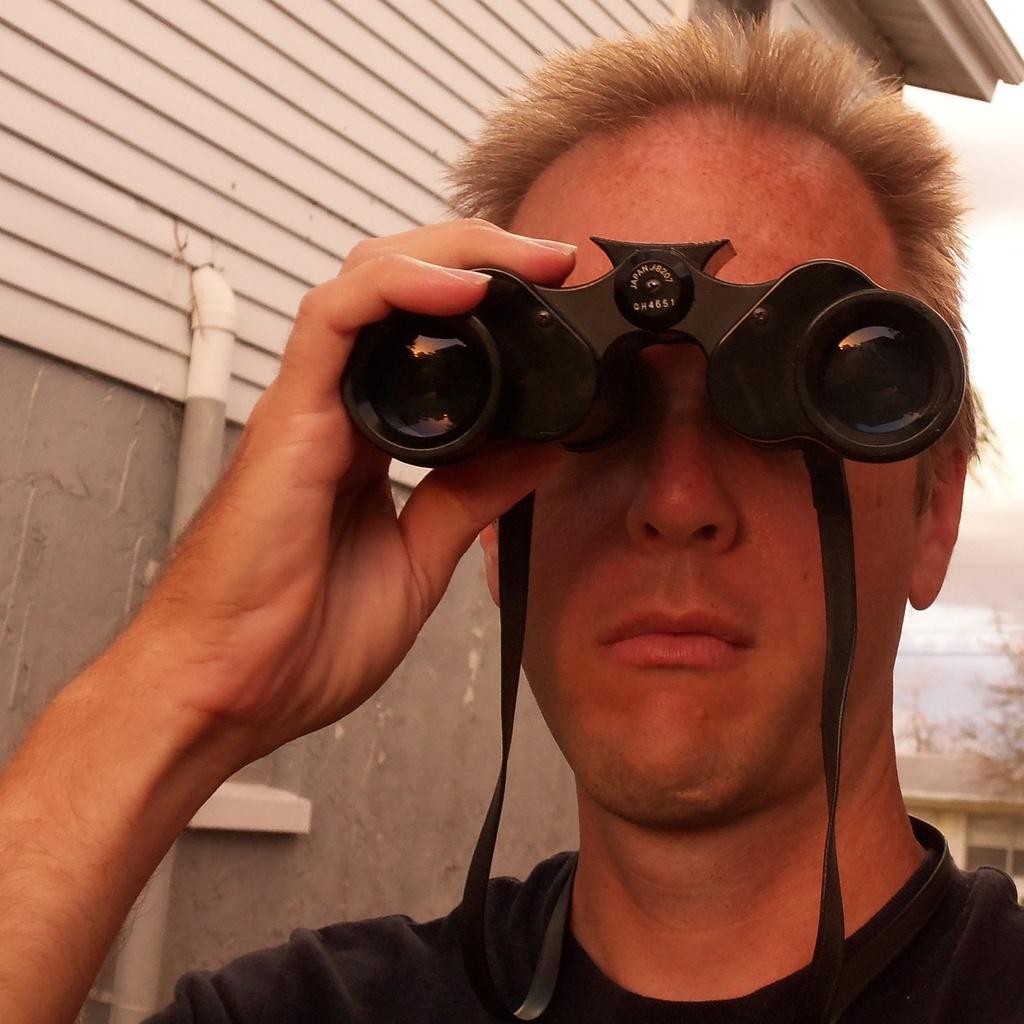Describe this image in one or two sentences. There is a person holding a binocular. In the back there's a wall. On that there is a pipe. 